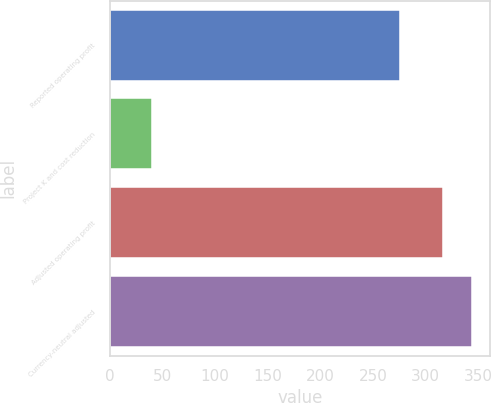Convert chart. <chart><loc_0><loc_0><loc_500><loc_500><bar_chart><fcel>Reported operating profit<fcel>Project K and cost reduction<fcel>Adjusted operating profit<fcel>Currency-neutral adjusted<nl><fcel>276<fcel>40<fcel>316<fcel>344.2<nl></chart> 